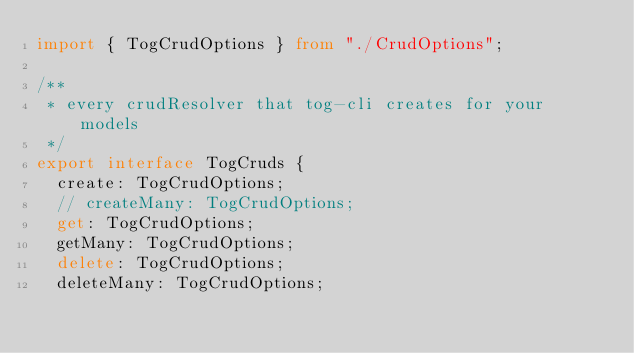<code> <loc_0><loc_0><loc_500><loc_500><_TypeScript_>import { TogCrudOptions } from "./CrudOptions";

/**
 * every crudResolver that tog-cli creates for your models
 */
export interface TogCruds {
  create: TogCrudOptions;
  // createMany: TogCrudOptions;
  get: TogCrudOptions;
  getMany: TogCrudOptions;
  delete: TogCrudOptions;
  deleteMany: TogCrudOptions;</code> 